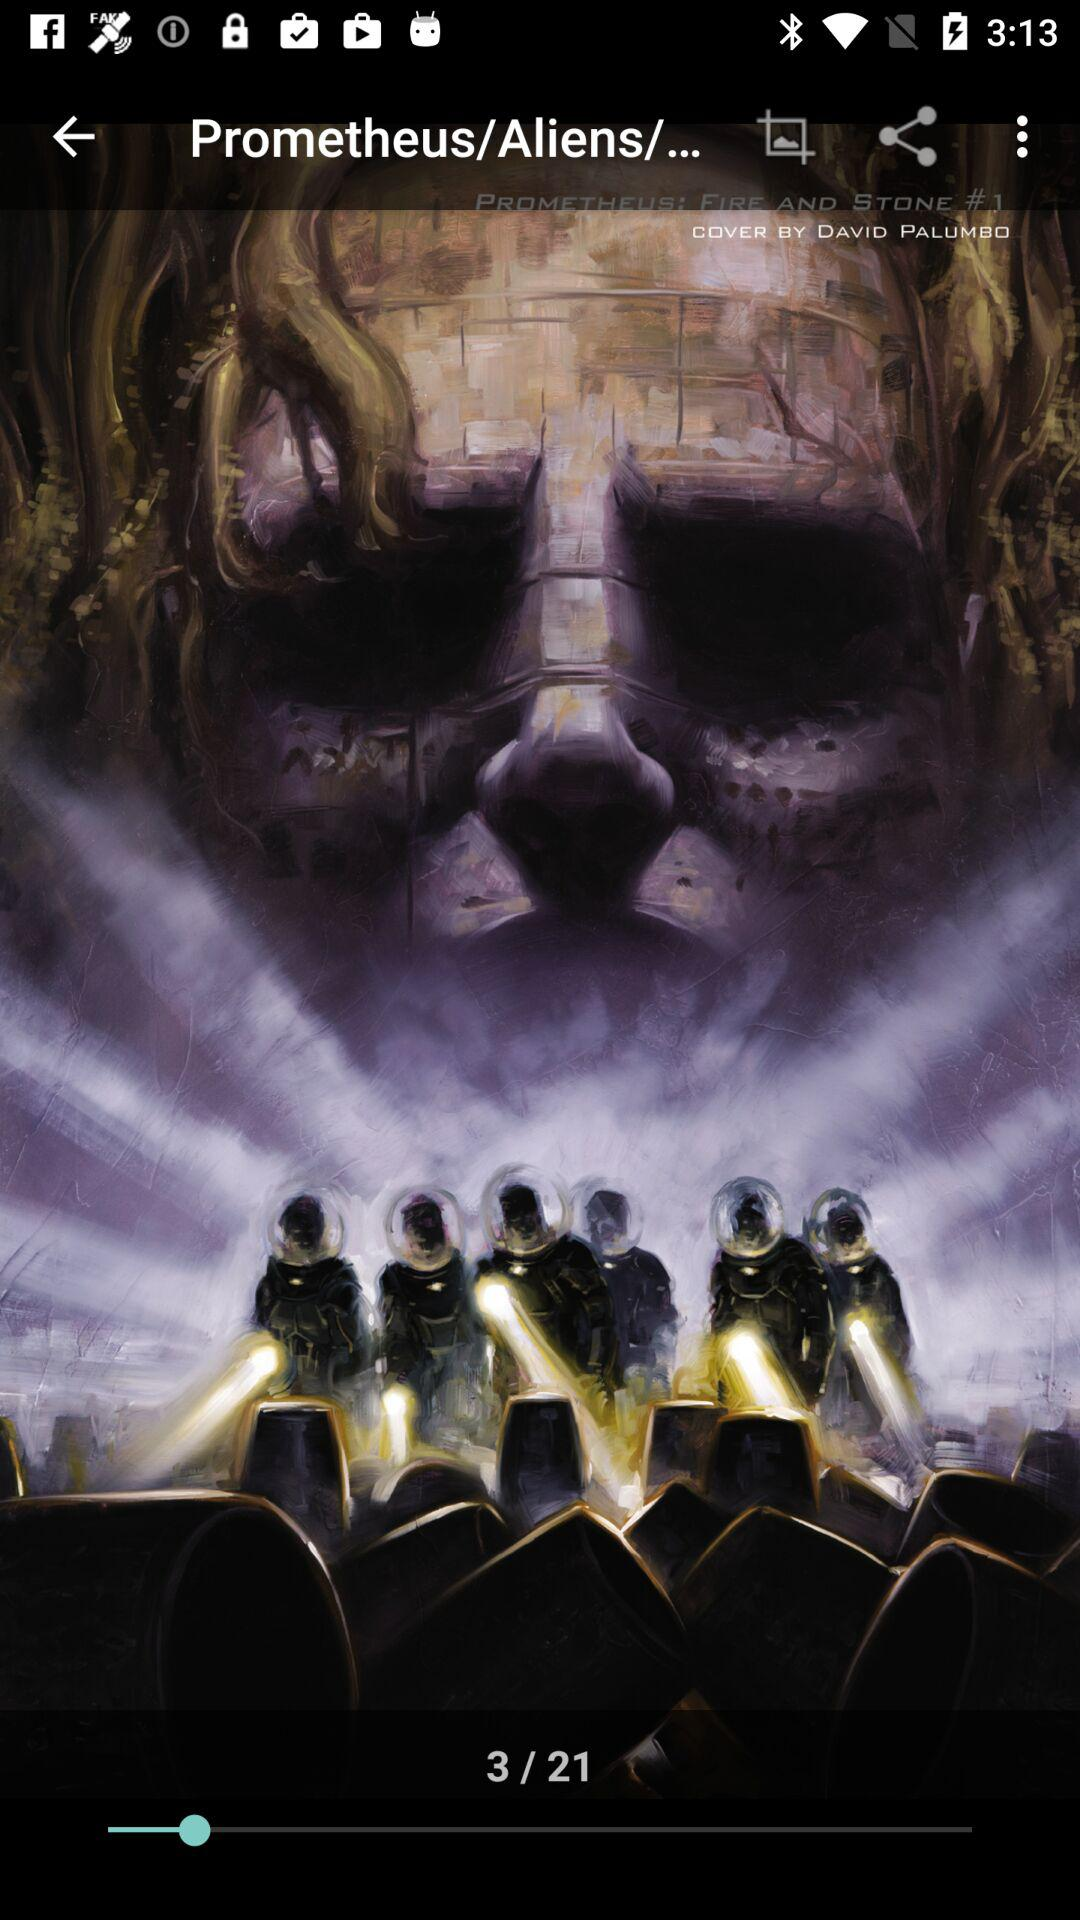When was "Prometheus/Aliens/..." released?
When the provided information is insufficient, respond with <no answer>. <no answer> 